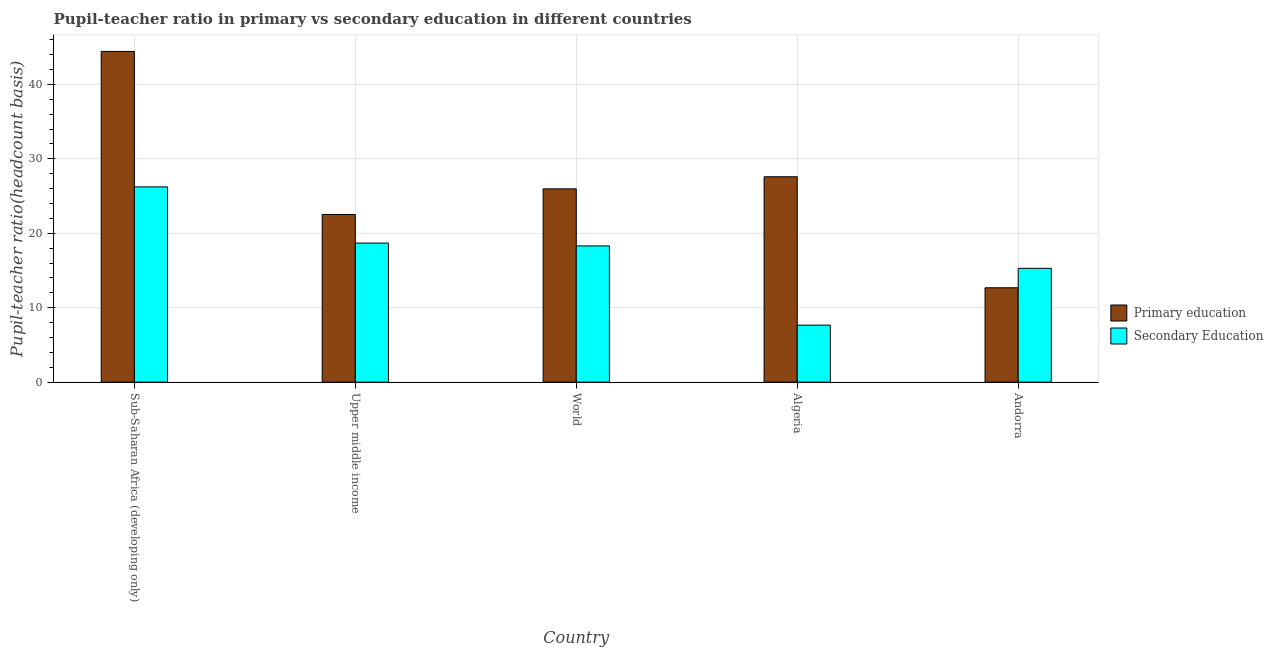How many different coloured bars are there?
Your answer should be compact. 2. How many groups of bars are there?
Your answer should be very brief. 5. What is the label of the 2nd group of bars from the left?
Your answer should be very brief. Upper middle income. In how many cases, is the number of bars for a given country not equal to the number of legend labels?
Provide a succinct answer. 0. What is the pupil-teacher ratio in primary education in Upper middle income?
Offer a very short reply. 22.53. Across all countries, what is the maximum pupil-teacher ratio in primary education?
Your answer should be very brief. 44.43. Across all countries, what is the minimum pupil teacher ratio on secondary education?
Keep it short and to the point. 7.66. In which country was the pupil teacher ratio on secondary education maximum?
Provide a succinct answer. Sub-Saharan Africa (developing only). In which country was the pupil-teacher ratio in primary education minimum?
Your answer should be very brief. Andorra. What is the total pupil-teacher ratio in primary education in the graph?
Offer a terse response. 133.2. What is the difference between the pupil-teacher ratio in primary education in Sub-Saharan Africa (developing only) and that in Upper middle income?
Offer a very short reply. 21.91. What is the difference between the pupil teacher ratio on secondary education in Sub-Saharan Africa (developing only) and the pupil-teacher ratio in primary education in Andorra?
Keep it short and to the point. 13.55. What is the average pupil teacher ratio on secondary education per country?
Your answer should be compact. 17.23. What is the difference between the pupil-teacher ratio in primary education and pupil teacher ratio on secondary education in Algeria?
Ensure brevity in your answer.  19.94. What is the ratio of the pupil-teacher ratio in primary education in Upper middle income to that in World?
Offer a terse response. 0.87. What is the difference between the highest and the second highest pupil teacher ratio on secondary education?
Your answer should be very brief. 7.55. What is the difference between the highest and the lowest pupil teacher ratio on secondary education?
Keep it short and to the point. 18.58. In how many countries, is the pupil-teacher ratio in primary education greater than the average pupil-teacher ratio in primary education taken over all countries?
Give a very brief answer. 2. Is the sum of the pupil-teacher ratio in primary education in Algeria and Upper middle income greater than the maximum pupil teacher ratio on secondary education across all countries?
Your response must be concise. Yes. What does the 1st bar from the left in Sub-Saharan Africa (developing only) represents?
Give a very brief answer. Primary education. What does the 2nd bar from the right in Algeria represents?
Ensure brevity in your answer.  Primary education. Are all the bars in the graph horizontal?
Give a very brief answer. No. How many countries are there in the graph?
Offer a very short reply. 5. Are the values on the major ticks of Y-axis written in scientific E-notation?
Your response must be concise. No. Does the graph contain grids?
Your answer should be very brief. Yes. Where does the legend appear in the graph?
Keep it short and to the point. Center right. How are the legend labels stacked?
Give a very brief answer. Vertical. What is the title of the graph?
Keep it short and to the point. Pupil-teacher ratio in primary vs secondary education in different countries. Does "Borrowers" appear as one of the legend labels in the graph?
Offer a terse response. No. What is the label or title of the X-axis?
Your answer should be very brief. Country. What is the label or title of the Y-axis?
Provide a short and direct response. Pupil-teacher ratio(headcount basis). What is the Pupil-teacher ratio(headcount basis) of Primary education in Sub-Saharan Africa (developing only)?
Your answer should be compact. 44.43. What is the Pupil-teacher ratio(headcount basis) of Secondary Education in Sub-Saharan Africa (developing only)?
Provide a short and direct response. 26.23. What is the Pupil-teacher ratio(headcount basis) in Primary education in Upper middle income?
Keep it short and to the point. 22.53. What is the Pupil-teacher ratio(headcount basis) of Secondary Education in Upper middle income?
Provide a short and direct response. 18.68. What is the Pupil-teacher ratio(headcount basis) of Primary education in World?
Your response must be concise. 25.97. What is the Pupil-teacher ratio(headcount basis) in Secondary Education in World?
Offer a very short reply. 18.3. What is the Pupil-teacher ratio(headcount basis) in Primary education in Algeria?
Provide a short and direct response. 27.59. What is the Pupil-teacher ratio(headcount basis) in Secondary Education in Algeria?
Offer a terse response. 7.66. What is the Pupil-teacher ratio(headcount basis) of Primary education in Andorra?
Give a very brief answer. 12.68. What is the Pupil-teacher ratio(headcount basis) in Secondary Education in Andorra?
Give a very brief answer. 15.29. Across all countries, what is the maximum Pupil-teacher ratio(headcount basis) in Primary education?
Your answer should be very brief. 44.43. Across all countries, what is the maximum Pupil-teacher ratio(headcount basis) in Secondary Education?
Make the answer very short. 26.23. Across all countries, what is the minimum Pupil-teacher ratio(headcount basis) of Primary education?
Provide a succinct answer. 12.68. Across all countries, what is the minimum Pupil-teacher ratio(headcount basis) of Secondary Education?
Your answer should be very brief. 7.66. What is the total Pupil-teacher ratio(headcount basis) of Primary education in the graph?
Offer a very short reply. 133.2. What is the total Pupil-teacher ratio(headcount basis) in Secondary Education in the graph?
Provide a short and direct response. 86.17. What is the difference between the Pupil-teacher ratio(headcount basis) in Primary education in Sub-Saharan Africa (developing only) and that in Upper middle income?
Offer a terse response. 21.91. What is the difference between the Pupil-teacher ratio(headcount basis) of Secondary Education in Sub-Saharan Africa (developing only) and that in Upper middle income?
Offer a terse response. 7.55. What is the difference between the Pupil-teacher ratio(headcount basis) in Primary education in Sub-Saharan Africa (developing only) and that in World?
Give a very brief answer. 18.46. What is the difference between the Pupil-teacher ratio(headcount basis) in Secondary Education in Sub-Saharan Africa (developing only) and that in World?
Offer a terse response. 7.93. What is the difference between the Pupil-teacher ratio(headcount basis) of Primary education in Sub-Saharan Africa (developing only) and that in Algeria?
Your response must be concise. 16.84. What is the difference between the Pupil-teacher ratio(headcount basis) of Secondary Education in Sub-Saharan Africa (developing only) and that in Algeria?
Provide a succinct answer. 18.57. What is the difference between the Pupil-teacher ratio(headcount basis) in Primary education in Sub-Saharan Africa (developing only) and that in Andorra?
Keep it short and to the point. 31.75. What is the difference between the Pupil-teacher ratio(headcount basis) in Secondary Education in Sub-Saharan Africa (developing only) and that in Andorra?
Keep it short and to the point. 10.94. What is the difference between the Pupil-teacher ratio(headcount basis) in Primary education in Upper middle income and that in World?
Offer a very short reply. -3.44. What is the difference between the Pupil-teacher ratio(headcount basis) in Secondary Education in Upper middle income and that in World?
Keep it short and to the point. 0.38. What is the difference between the Pupil-teacher ratio(headcount basis) of Primary education in Upper middle income and that in Algeria?
Ensure brevity in your answer.  -5.07. What is the difference between the Pupil-teacher ratio(headcount basis) of Secondary Education in Upper middle income and that in Algeria?
Your answer should be very brief. 11.03. What is the difference between the Pupil-teacher ratio(headcount basis) of Primary education in Upper middle income and that in Andorra?
Make the answer very short. 9.85. What is the difference between the Pupil-teacher ratio(headcount basis) of Secondary Education in Upper middle income and that in Andorra?
Your answer should be compact. 3.39. What is the difference between the Pupil-teacher ratio(headcount basis) of Primary education in World and that in Algeria?
Your response must be concise. -1.62. What is the difference between the Pupil-teacher ratio(headcount basis) in Secondary Education in World and that in Algeria?
Make the answer very short. 10.64. What is the difference between the Pupil-teacher ratio(headcount basis) in Primary education in World and that in Andorra?
Give a very brief answer. 13.29. What is the difference between the Pupil-teacher ratio(headcount basis) in Secondary Education in World and that in Andorra?
Give a very brief answer. 3.01. What is the difference between the Pupil-teacher ratio(headcount basis) in Primary education in Algeria and that in Andorra?
Give a very brief answer. 14.91. What is the difference between the Pupil-teacher ratio(headcount basis) of Secondary Education in Algeria and that in Andorra?
Give a very brief answer. -7.63. What is the difference between the Pupil-teacher ratio(headcount basis) in Primary education in Sub-Saharan Africa (developing only) and the Pupil-teacher ratio(headcount basis) in Secondary Education in Upper middle income?
Ensure brevity in your answer.  25.75. What is the difference between the Pupil-teacher ratio(headcount basis) of Primary education in Sub-Saharan Africa (developing only) and the Pupil-teacher ratio(headcount basis) of Secondary Education in World?
Give a very brief answer. 26.13. What is the difference between the Pupil-teacher ratio(headcount basis) in Primary education in Sub-Saharan Africa (developing only) and the Pupil-teacher ratio(headcount basis) in Secondary Education in Algeria?
Provide a succinct answer. 36.77. What is the difference between the Pupil-teacher ratio(headcount basis) of Primary education in Sub-Saharan Africa (developing only) and the Pupil-teacher ratio(headcount basis) of Secondary Education in Andorra?
Give a very brief answer. 29.14. What is the difference between the Pupil-teacher ratio(headcount basis) of Primary education in Upper middle income and the Pupil-teacher ratio(headcount basis) of Secondary Education in World?
Your answer should be compact. 4.22. What is the difference between the Pupil-teacher ratio(headcount basis) of Primary education in Upper middle income and the Pupil-teacher ratio(headcount basis) of Secondary Education in Algeria?
Offer a terse response. 14.87. What is the difference between the Pupil-teacher ratio(headcount basis) of Primary education in Upper middle income and the Pupil-teacher ratio(headcount basis) of Secondary Education in Andorra?
Make the answer very short. 7.23. What is the difference between the Pupil-teacher ratio(headcount basis) of Primary education in World and the Pupil-teacher ratio(headcount basis) of Secondary Education in Algeria?
Offer a very short reply. 18.31. What is the difference between the Pupil-teacher ratio(headcount basis) of Primary education in World and the Pupil-teacher ratio(headcount basis) of Secondary Education in Andorra?
Provide a succinct answer. 10.68. What is the difference between the Pupil-teacher ratio(headcount basis) of Primary education in Algeria and the Pupil-teacher ratio(headcount basis) of Secondary Education in Andorra?
Offer a very short reply. 12.3. What is the average Pupil-teacher ratio(headcount basis) in Primary education per country?
Provide a short and direct response. 26.64. What is the average Pupil-teacher ratio(headcount basis) in Secondary Education per country?
Your response must be concise. 17.23. What is the difference between the Pupil-teacher ratio(headcount basis) of Primary education and Pupil-teacher ratio(headcount basis) of Secondary Education in Sub-Saharan Africa (developing only)?
Make the answer very short. 18.2. What is the difference between the Pupil-teacher ratio(headcount basis) in Primary education and Pupil-teacher ratio(headcount basis) in Secondary Education in Upper middle income?
Your answer should be very brief. 3.84. What is the difference between the Pupil-teacher ratio(headcount basis) of Primary education and Pupil-teacher ratio(headcount basis) of Secondary Education in World?
Offer a very short reply. 7.67. What is the difference between the Pupil-teacher ratio(headcount basis) in Primary education and Pupil-teacher ratio(headcount basis) in Secondary Education in Algeria?
Keep it short and to the point. 19.94. What is the difference between the Pupil-teacher ratio(headcount basis) of Primary education and Pupil-teacher ratio(headcount basis) of Secondary Education in Andorra?
Offer a terse response. -2.61. What is the ratio of the Pupil-teacher ratio(headcount basis) of Primary education in Sub-Saharan Africa (developing only) to that in Upper middle income?
Your answer should be compact. 1.97. What is the ratio of the Pupil-teacher ratio(headcount basis) of Secondary Education in Sub-Saharan Africa (developing only) to that in Upper middle income?
Keep it short and to the point. 1.4. What is the ratio of the Pupil-teacher ratio(headcount basis) in Primary education in Sub-Saharan Africa (developing only) to that in World?
Offer a very short reply. 1.71. What is the ratio of the Pupil-teacher ratio(headcount basis) of Secondary Education in Sub-Saharan Africa (developing only) to that in World?
Offer a very short reply. 1.43. What is the ratio of the Pupil-teacher ratio(headcount basis) of Primary education in Sub-Saharan Africa (developing only) to that in Algeria?
Ensure brevity in your answer.  1.61. What is the ratio of the Pupil-teacher ratio(headcount basis) in Secondary Education in Sub-Saharan Africa (developing only) to that in Algeria?
Keep it short and to the point. 3.43. What is the ratio of the Pupil-teacher ratio(headcount basis) in Primary education in Sub-Saharan Africa (developing only) to that in Andorra?
Keep it short and to the point. 3.5. What is the ratio of the Pupil-teacher ratio(headcount basis) of Secondary Education in Sub-Saharan Africa (developing only) to that in Andorra?
Offer a terse response. 1.72. What is the ratio of the Pupil-teacher ratio(headcount basis) of Primary education in Upper middle income to that in World?
Ensure brevity in your answer.  0.87. What is the ratio of the Pupil-teacher ratio(headcount basis) of Secondary Education in Upper middle income to that in World?
Ensure brevity in your answer.  1.02. What is the ratio of the Pupil-teacher ratio(headcount basis) in Primary education in Upper middle income to that in Algeria?
Keep it short and to the point. 0.82. What is the ratio of the Pupil-teacher ratio(headcount basis) in Secondary Education in Upper middle income to that in Algeria?
Keep it short and to the point. 2.44. What is the ratio of the Pupil-teacher ratio(headcount basis) in Primary education in Upper middle income to that in Andorra?
Offer a very short reply. 1.78. What is the ratio of the Pupil-teacher ratio(headcount basis) of Secondary Education in Upper middle income to that in Andorra?
Offer a very short reply. 1.22. What is the ratio of the Pupil-teacher ratio(headcount basis) in Primary education in World to that in Algeria?
Offer a terse response. 0.94. What is the ratio of the Pupil-teacher ratio(headcount basis) of Secondary Education in World to that in Algeria?
Offer a very short reply. 2.39. What is the ratio of the Pupil-teacher ratio(headcount basis) of Primary education in World to that in Andorra?
Offer a terse response. 2.05. What is the ratio of the Pupil-teacher ratio(headcount basis) in Secondary Education in World to that in Andorra?
Provide a succinct answer. 1.2. What is the ratio of the Pupil-teacher ratio(headcount basis) in Primary education in Algeria to that in Andorra?
Ensure brevity in your answer.  2.18. What is the ratio of the Pupil-teacher ratio(headcount basis) of Secondary Education in Algeria to that in Andorra?
Ensure brevity in your answer.  0.5. What is the difference between the highest and the second highest Pupil-teacher ratio(headcount basis) in Primary education?
Keep it short and to the point. 16.84. What is the difference between the highest and the second highest Pupil-teacher ratio(headcount basis) of Secondary Education?
Your answer should be compact. 7.55. What is the difference between the highest and the lowest Pupil-teacher ratio(headcount basis) in Primary education?
Offer a very short reply. 31.75. What is the difference between the highest and the lowest Pupil-teacher ratio(headcount basis) of Secondary Education?
Your response must be concise. 18.57. 